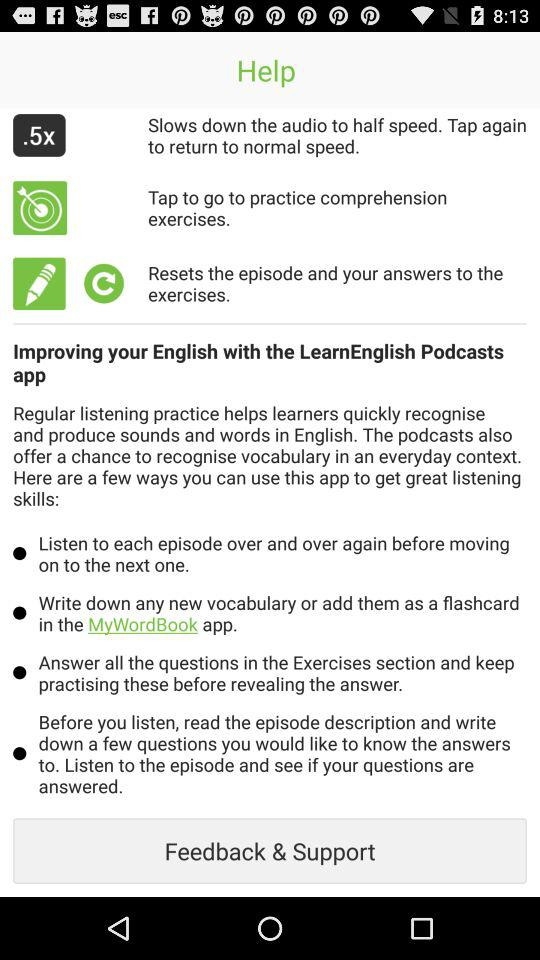How to improve English? Improve your English with the "LearnEnglish Podcasts" app. 